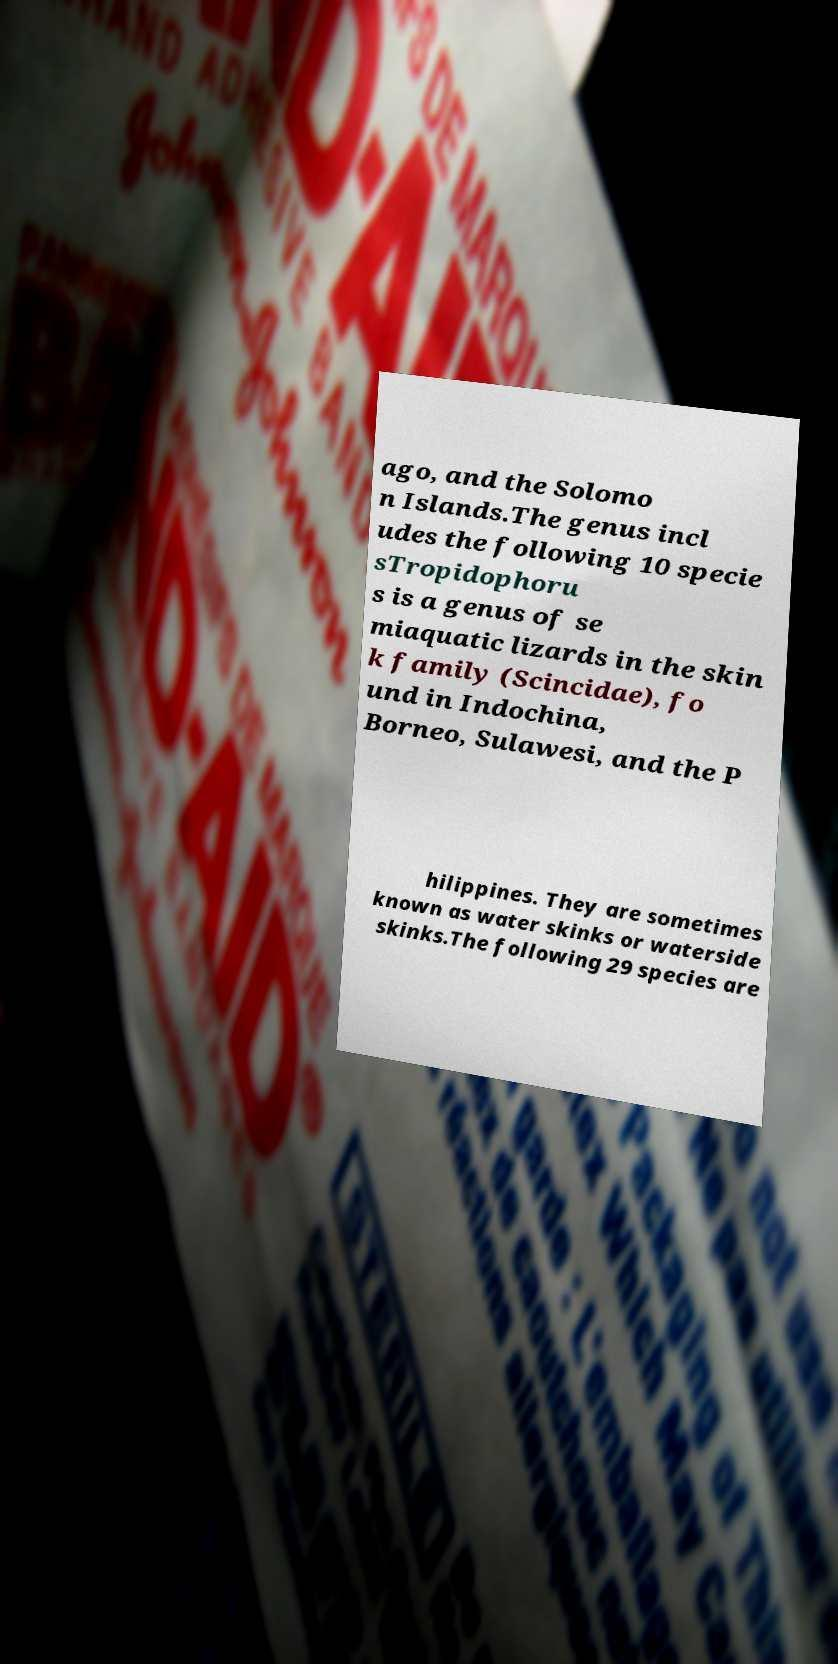Please read and relay the text visible in this image. What does it say? ago, and the Solomo n Islands.The genus incl udes the following 10 specie sTropidophoru s is a genus of se miaquatic lizards in the skin k family (Scincidae), fo und in Indochina, Borneo, Sulawesi, and the P hilippines. They are sometimes known as water skinks or waterside skinks.The following 29 species are 